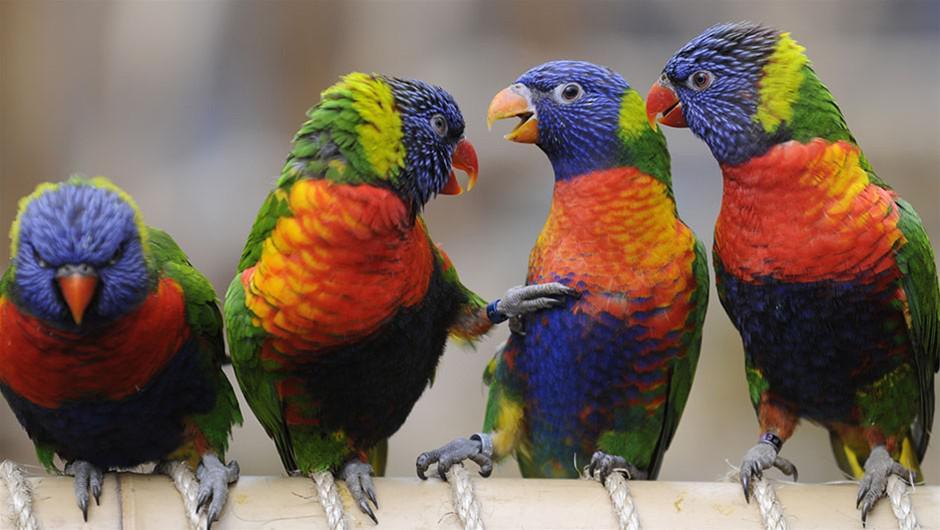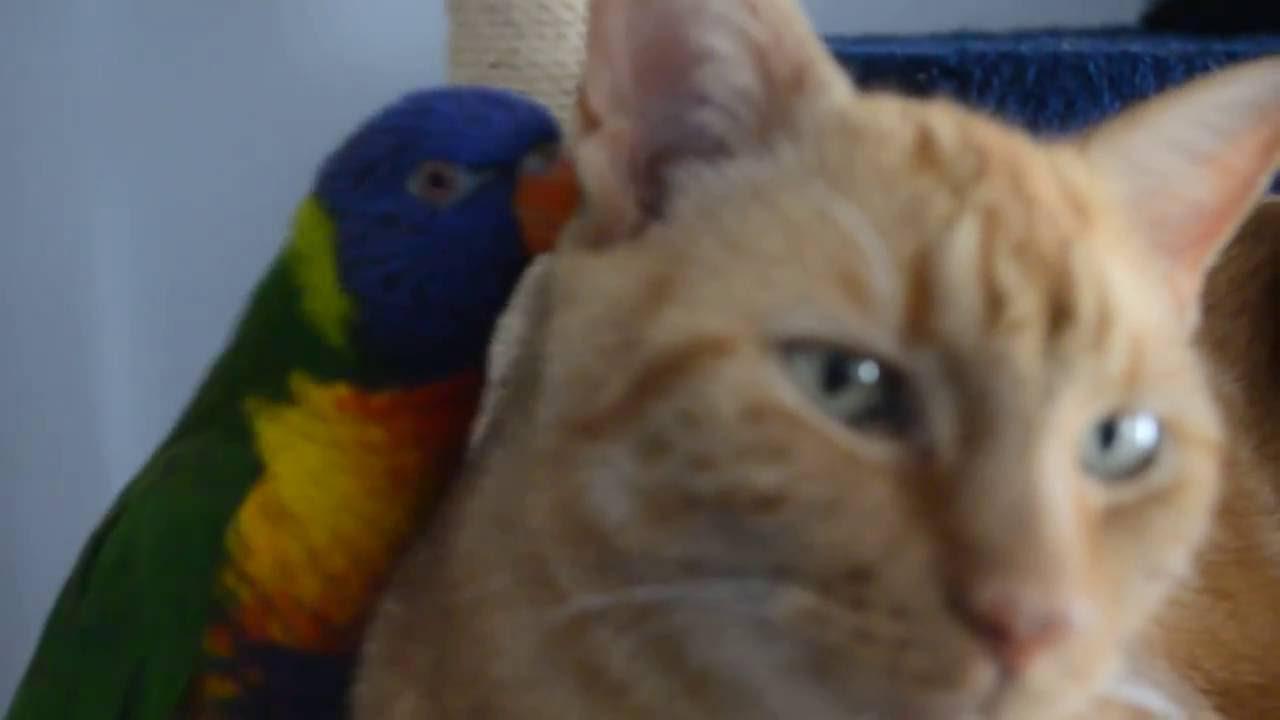The first image is the image on the left, the second image is the image on the right. Given the left and right images, does the statement "The bird in the image on the left is standing on a person." hold true? Answer yes or no. No. The first image is the image on the left, the second image is the image on the right. Considering the images on both sides, is "Left image shows a colorful parrot near a person's head." valid? Answer yes or no. No. 